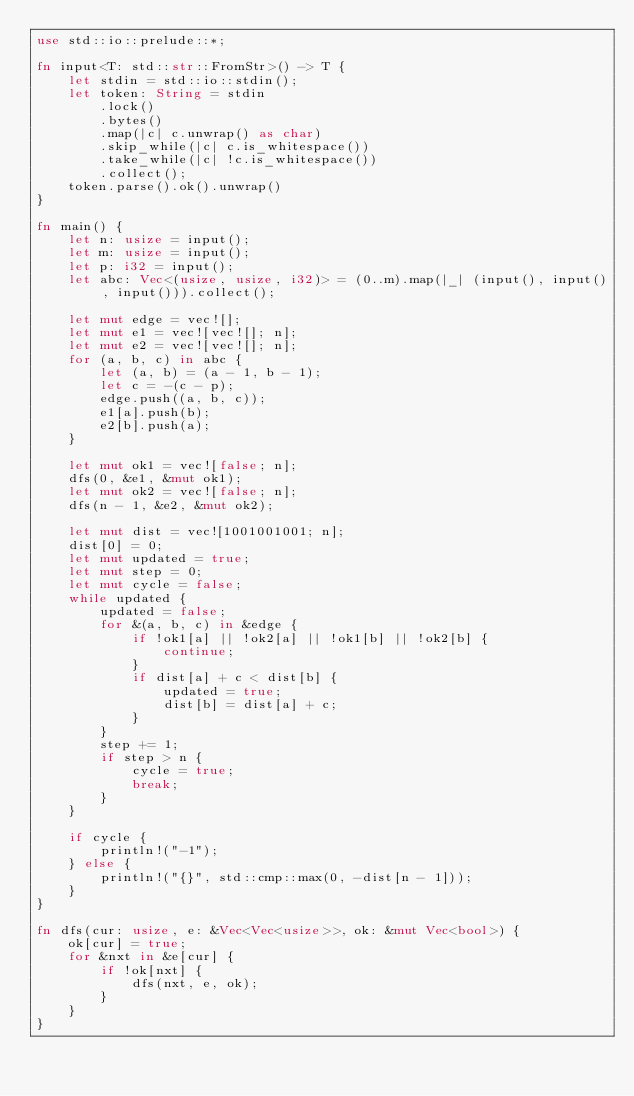Convert code to text. <code><loc_0><loc_0><loc_500><loc_500><_Rust_>use std::io::prelude::*;

fn input<T: std::str::FromStr>() -> T {
    let stdin = std::io::stdin();
    let token: String = stdin
        .lock()
        .bytes()
        .map(|c| c.unwrap() as char)
        .skip_while(|c| c.is_whitespace())
        .take_while(|c| !c.is_whitespace())
        .collect();
    token.parse().ok().unwrap()
}

fn main() {
    let n: usize = input();
    let m: usize = input();
    let p: i32 = input();
    let abc: Vec<(usize, usize, i32)> = (0..m).map(|_| (input(), input(), input())).collect();

    let mut edge = vec![];
    let mut e1 = vec![vec![]; n];
    let mut e2 = vec![vec![]; n];
    for (a, b, c) in abc {
        let (a, b) = (a - 1, b - 1);
        let c = -(c - p);
        edge.push((a, b, c));
        e1[a].push(b);
        e2[b].push(a);
    }

    let mut ok1 = vec![false; n];
    dfs(0, &e1, &mut ok1);
    let mut ok2 = vec![false; n];
    dfs(n - 1, &e2, &mut ok2);

    let mut dist = vec![1001001001; n];
    dist[0] = 0;
    let mut updated = true;
    let mut step = 0;
    let mut cycle = false;
    while updated {
        updated = false;
        for &(a, b, c) in &edge {
            if !ok1[a] || !ok2[a] || !ok1[b] || !ok2[b] {
                continue;
            }
            if dist[a] + c < dist[b] {
                updated = true;
                dist[b] = dist[a] + c;
            }
        }
        step += 1;
        if step > n {
            cycle = true;
            break;
        }
    }

    if cycle {
        println!("-1");
    } else {
        println!("{}", std::cmp::max(0, -dist[n - 1]));
    }
}

fn dfs(cur: usize, e: &Vec<Vec<usize>>, ok: &mut Vec<bool>) {
    ok[cur] = true;
    for &nxt in &e[cur] {
        if !ok[nxt] {
            dfs(nxt, e, ok);
        }
    }
}
</code> 